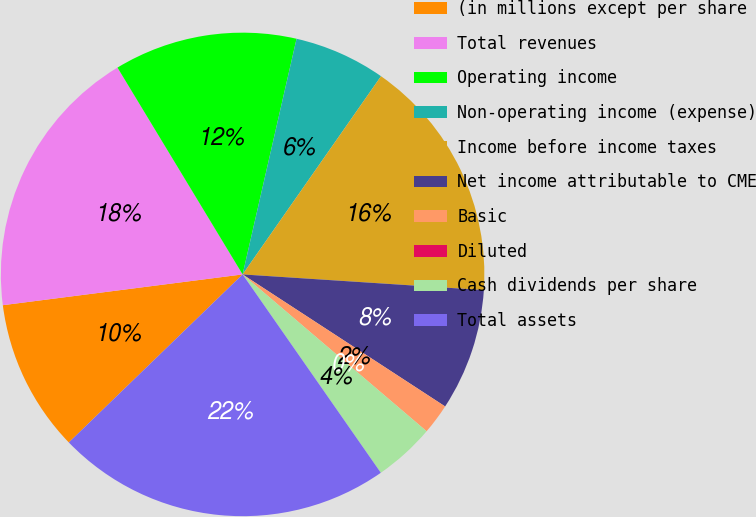<chart> <loc_0><loc_0><loc_500><loc_500><pie_chart><fcel>(in millions except per share<fcel>Total revenues<fcel>Operating income<fcel>Non-operating income (expense)<fcel>Income before income taxes<fcel>Net income attributable to CME<fcel>Basic<fcel>Diluted<fcel>Cash dividends per share<fcel>Total assets<nl><fcel>10.2%<fcel>18.37%<fcel>12.24%<fcel>6.12%<fcel>16.33%<fcel>8.16%<fcel>2.04%<fcel>0.0%<fcel>4.08%<fcel>22.45%<nl></chart> 